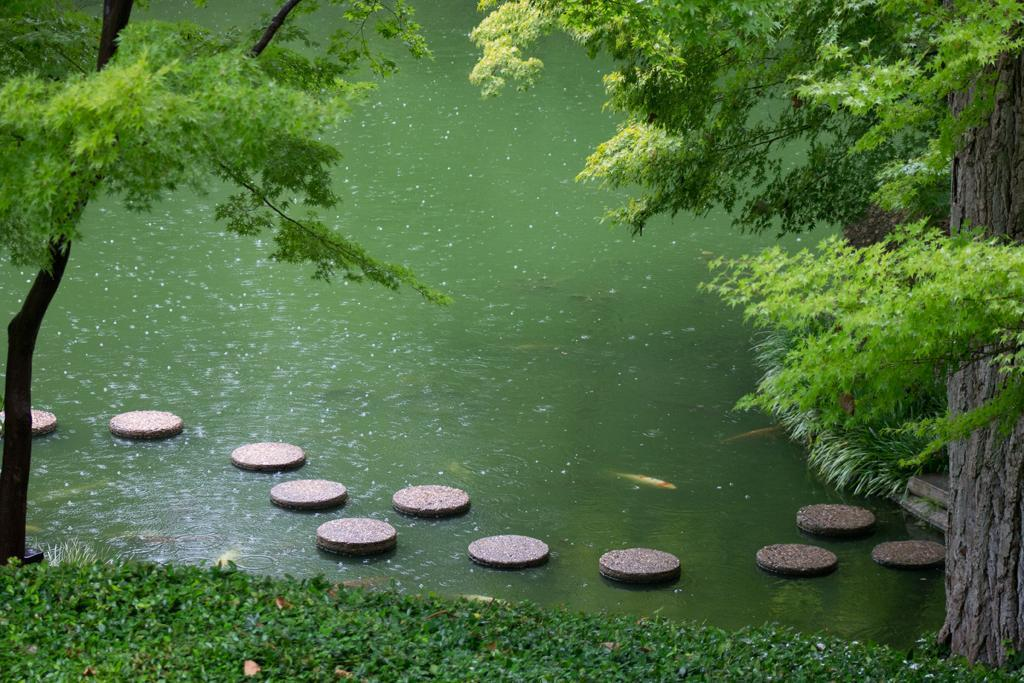What type of terrain is visible in the image? There is grass on the ground in the image. What natural element is present in the image? There is water visible in the image. What type of vegetation can be seen in the image? There are trees in the image, with some being green, black, and ash in color. What is floating on the surface of the water in the image? There are objects on the surface of the water in the image. Can you see a needle floating on the water in the image? No, there is no needle present in the image. Is there a yak grazing on the grass in the image? No, there is no yak present in the image. 